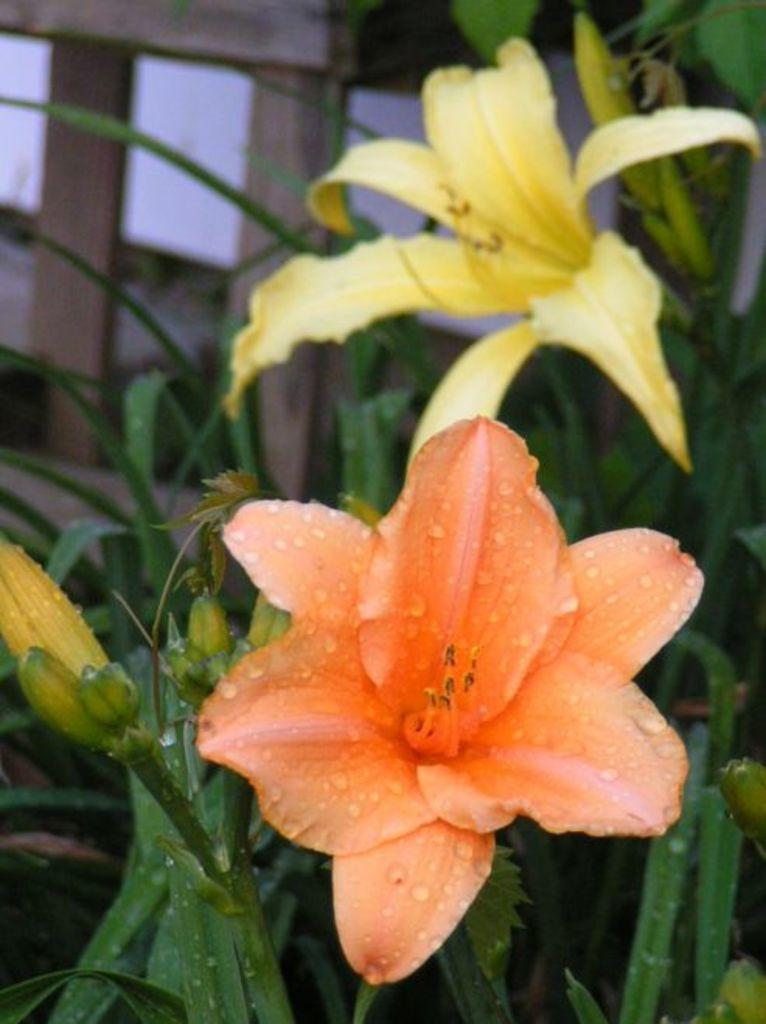What type of error can be found in the image? There is a transcription error in the image. What can be seen besides the error in the image? There is a yellow and orange flower in the image. What is visible in the background of the image? There is a fencing board visible in the background of the image. What type of ornament is hanging from the flower in the image? There is no ornament hanging from the flower in the image; it is a single flower with no additional decorations. 